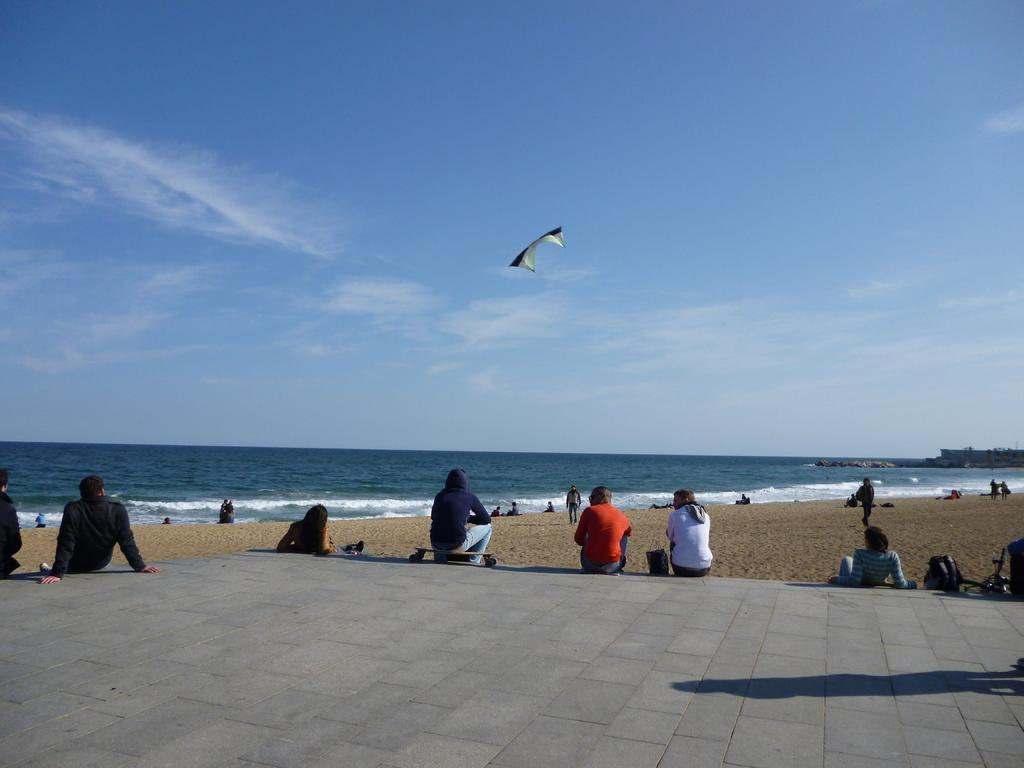How many people can be seen in the image? There are many people in the image. What are some of the people in the image doing? Some people are sitting. What can be seen in the background of the image? There is a sea shore visible in the background. What is flying in the image? There is an object flying in the image. What is visible in the sky in the background? The sky is visible in the background with clouds. What type of wheel can be seen on the nation in the image? There is no nation present in the image, nor is there a wheel visible. 